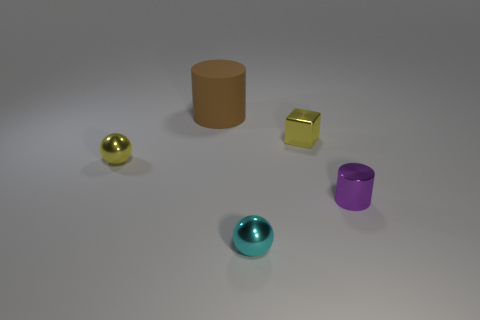If these objects were to be sold, which one might be the most expensive based on appearance? Based solely on appearance, the golden sphere might be considered the most expensive due to its lustrous finish and the common association of gold with value. However, without knowing the actual materials or craftsmanship involved, this is purely speculative. 